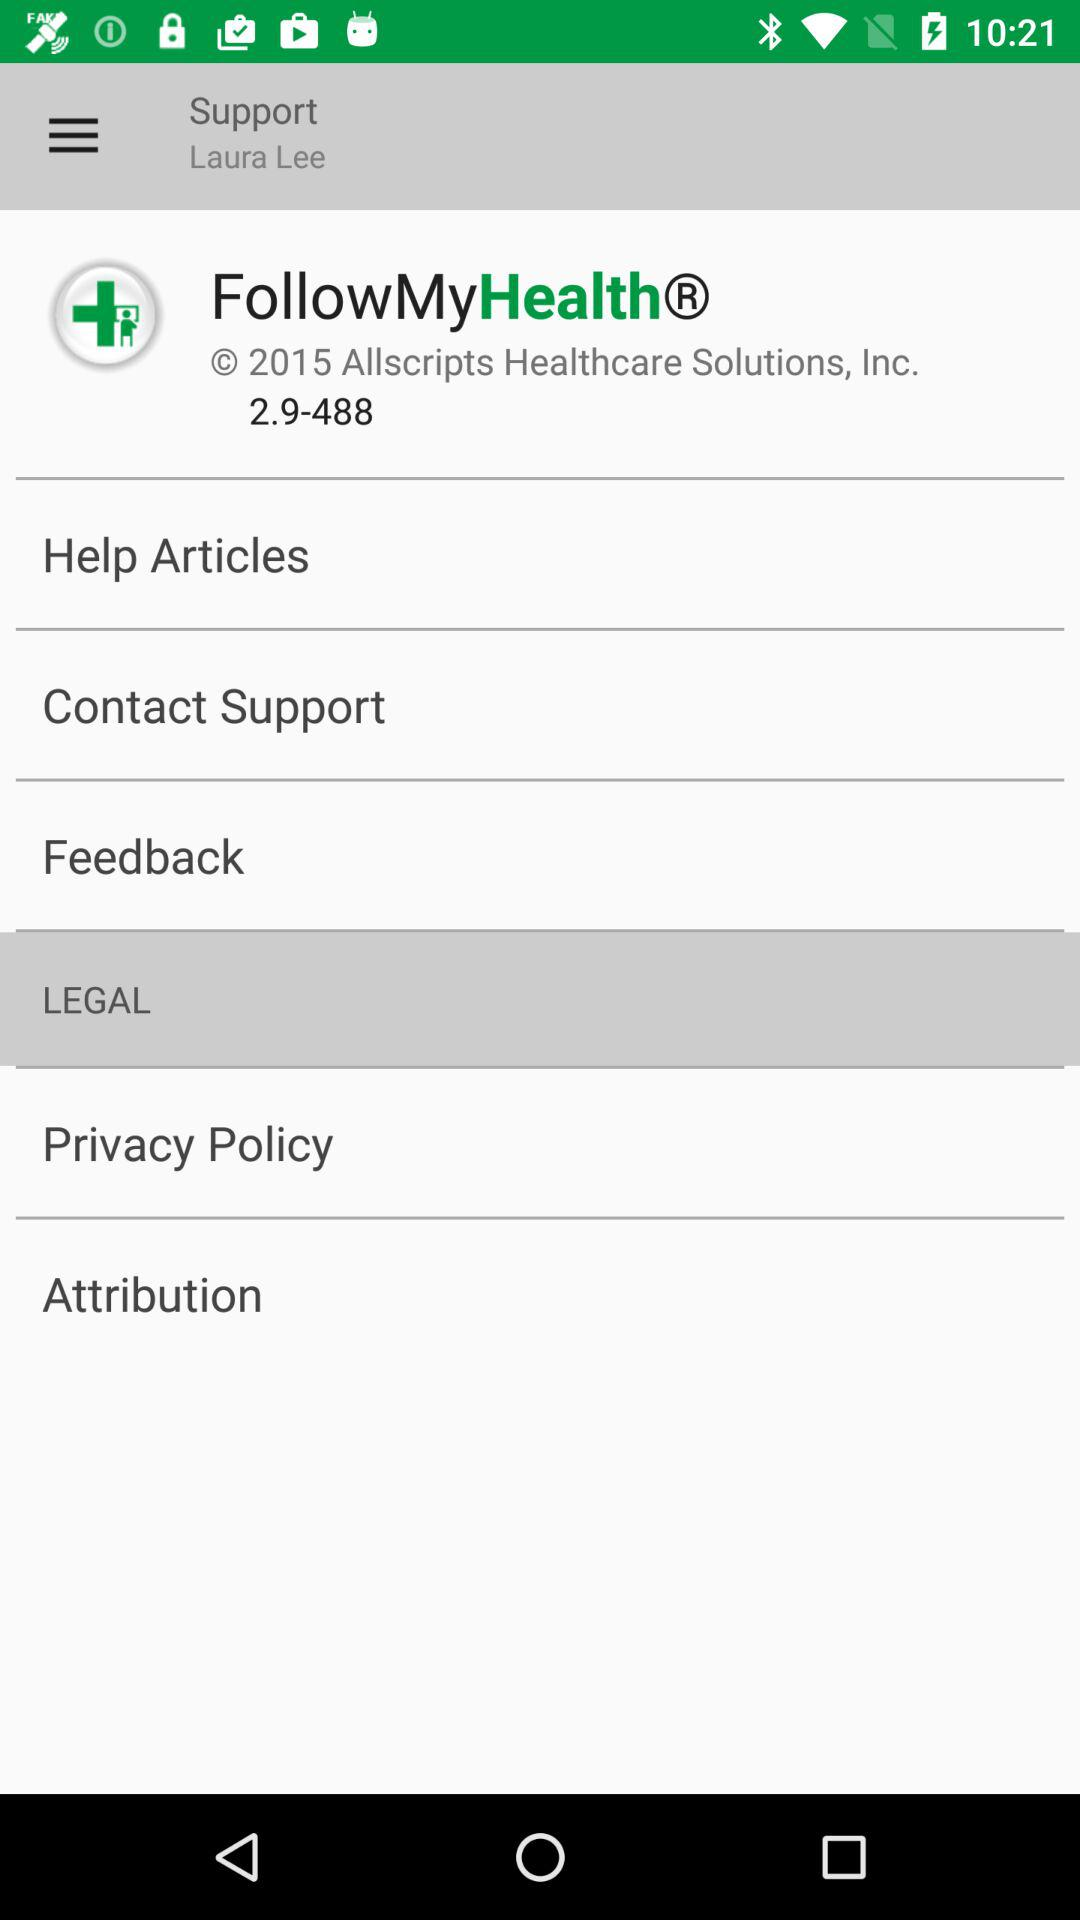Which item is currently selected in the menu? The currently selected item is "LEGAL". 